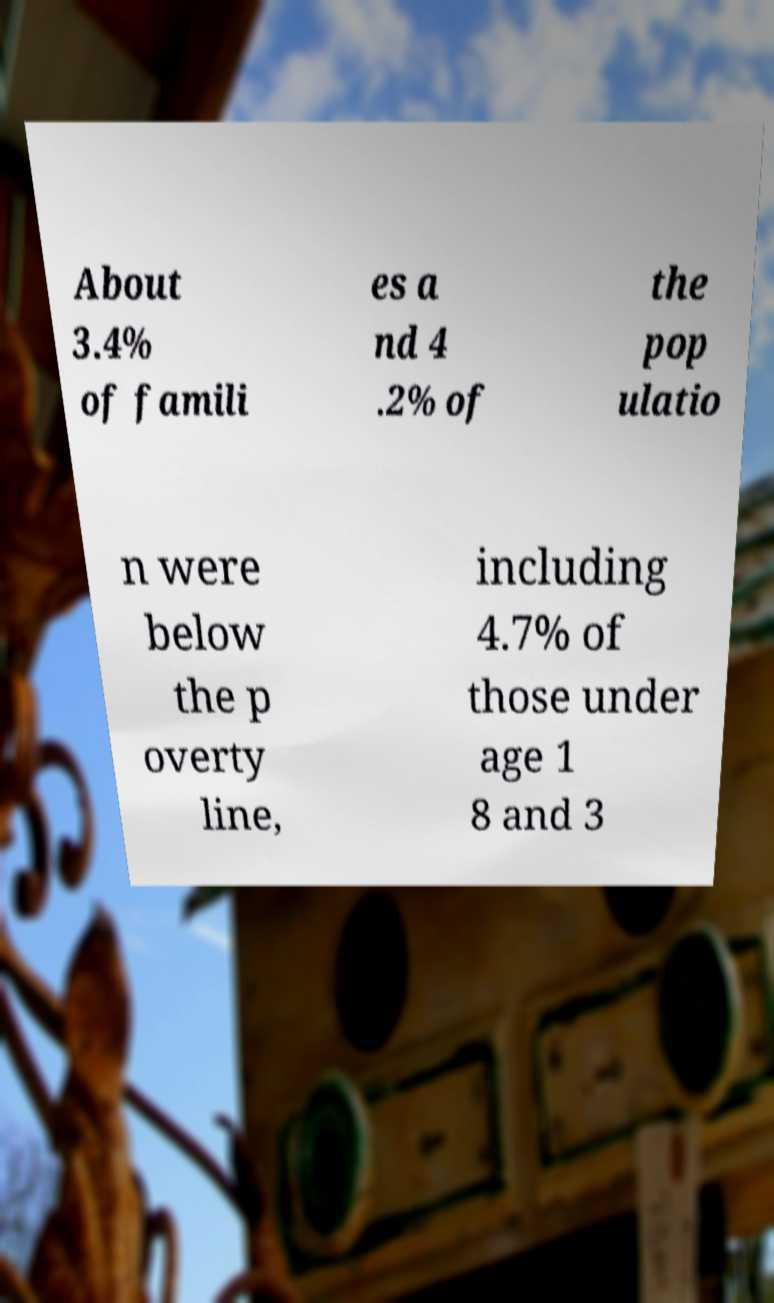What messages or text are displayed in this image? I need them in a readable, typed format. About 3.4% of famili es a nd 4 .2% of the pop ulatio n were below the p overty line, including 4.7% of those under age 1 8 and 3 